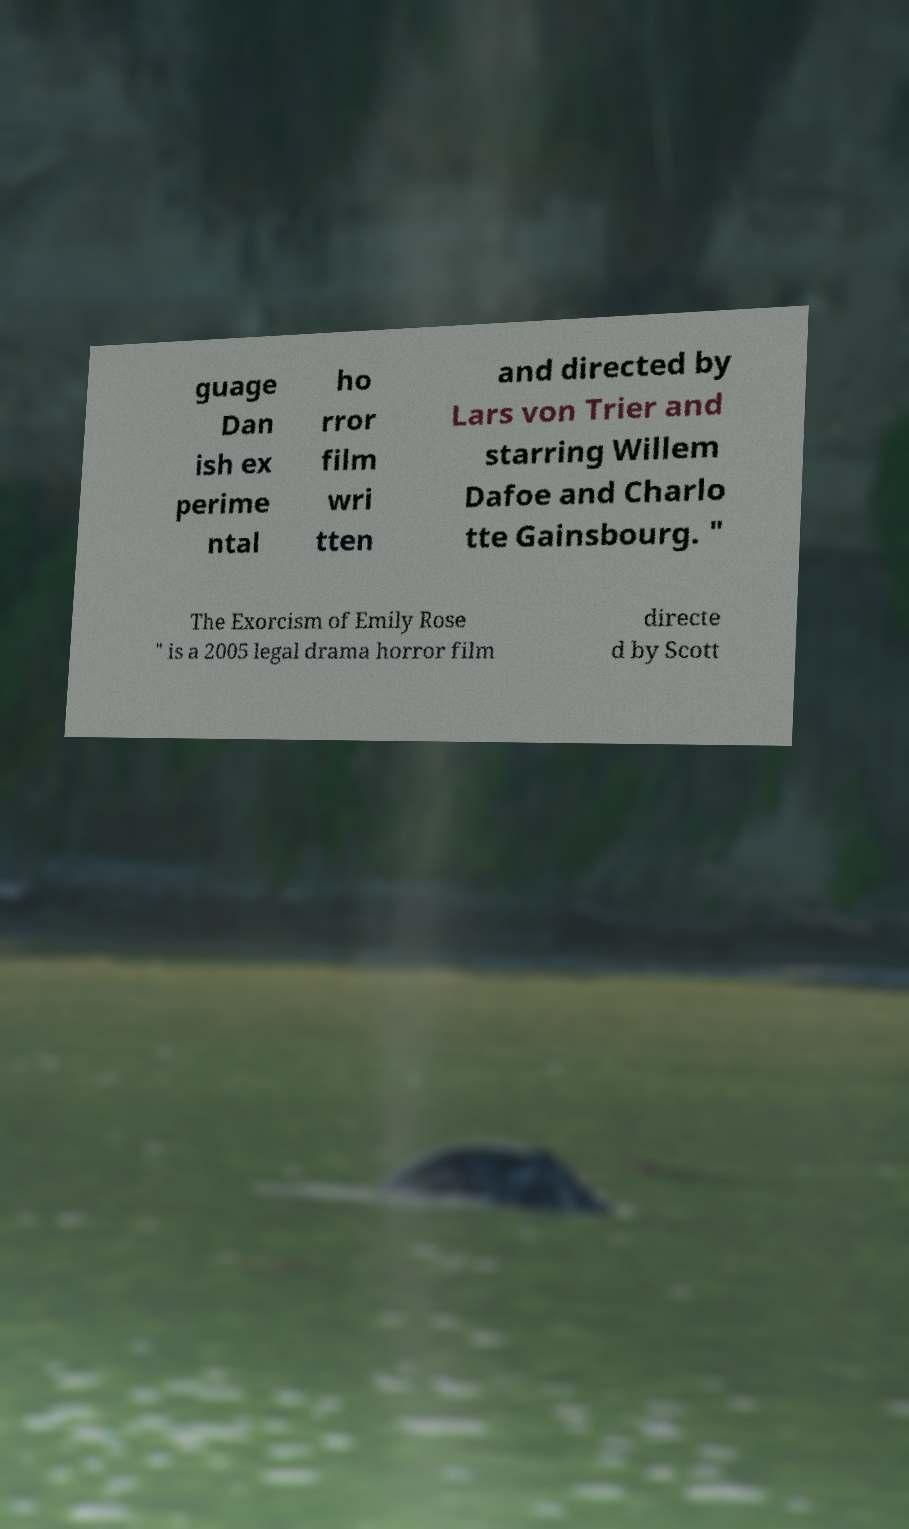I need the written content from this picture converted into text. Can you do that? guage Dan ish ex perime ntal ho rror film wri tten and directed by Lars von Trier and starring Willem Dafoe and Charlo tte Gainsbourg. " The Exorcism of Emily Rose " is a 2005 legal drama horror film directe d by Scott 